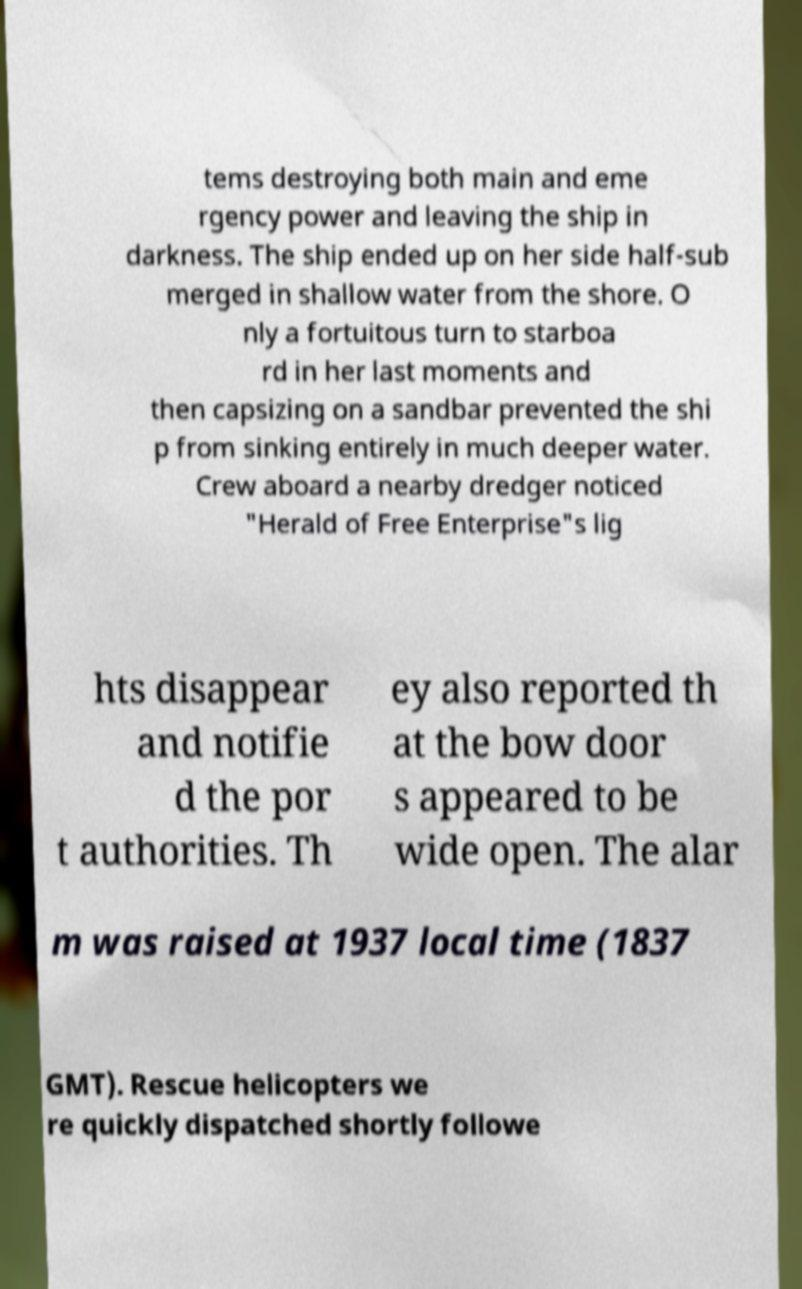What messages or text are displayed in this image? I need them in a readable, typed format. tems destroying both main and eme rgency power and leaving the ship in darkness. The ship ended up on her side half-sub merged in shallow water from the shore. O nly a fortuitous turn to starboa rd in her last moments and then capsizing on a sandbar prevented the shi p from sinking entirely in much deeper water. Crew aboard a nearby dredger noticed "Herald of Free Enterprise"s lig hts disappear and notifie d the por t authorities. Th ey also reported th at the bow door s appeared to be wide open. The alar m was raised at 1937 local time (1837 GMT). Rescue helicopters we re quickly dispatched shortly followe 